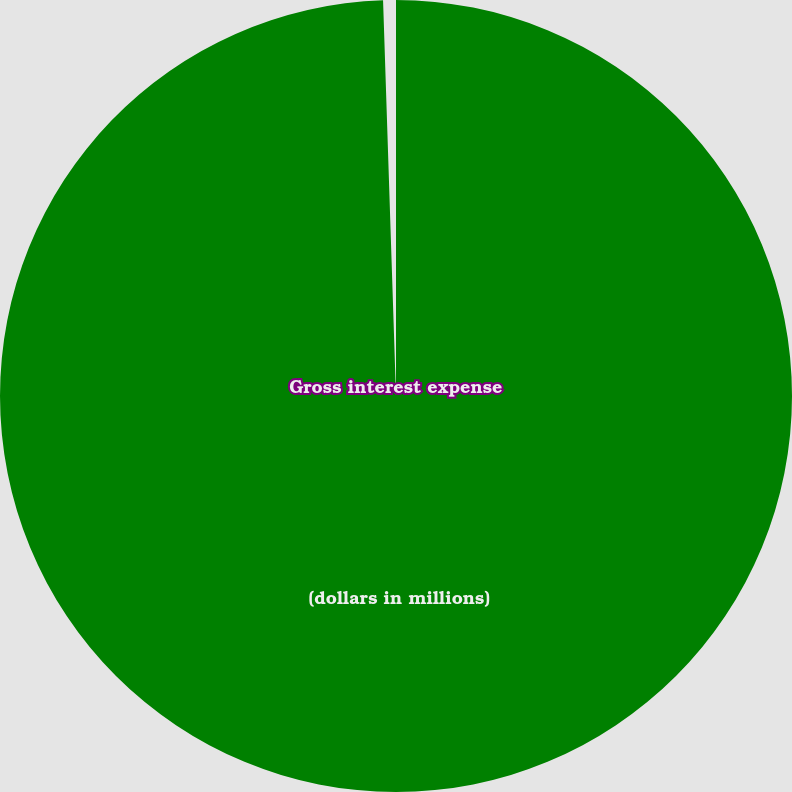Convert chart. <chart><loc_0><loc_0><loc_500><loc_500><pie_chart><fcel>(dollars in millions)<fcel>Gross interest expense<nl><fcel>99.48%<fcel>0.52%<nl></chart> 